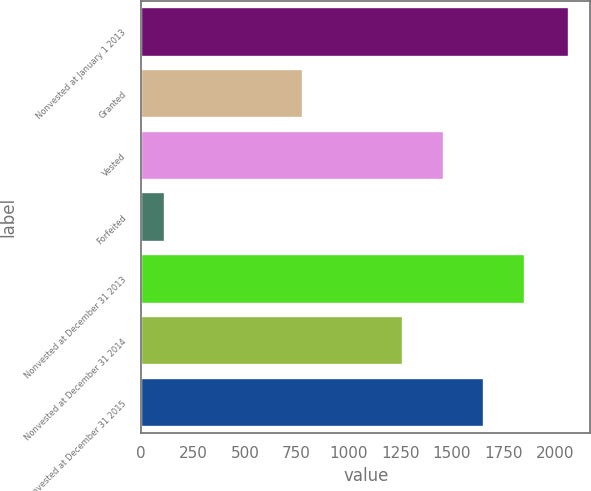Convert chart to OTSL. <chart><loc_0><loc_0><loc_500><loc_500><bar_chart><fcel>Nonvested at January 1 2013<fcel>Granted<fcel>Vested<fcel>Forfeited<fcel>Nonvested at December 31 2013<fcel>Nonvested at December 31 2014<fcel>Nonvested at December 31 2015<nl><fcel>2064<fcel>782<fcel>1461.1<fcel>113<fcel>1851.3<fcel>1266<fcel>1656.2<nl></chart> 